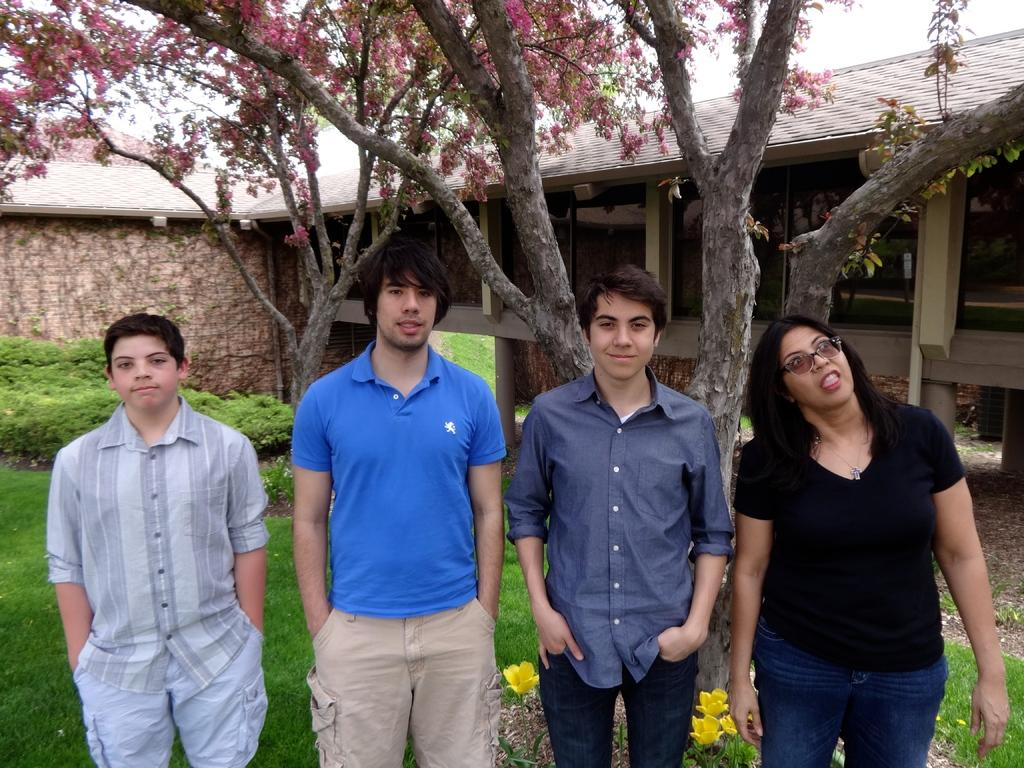What is the main focus of the image? There are people in the center of the image. What can be seen in the background of the image? In the background, there are flower trees, grassland, yellow color flowers, pillars, a pipe, a house, and the sky. Can you describe the vegetation in the background? The background features flower trees and yellow color flowers. What type of structure is visible in the background? There is a house in the background. Is there an airplane flying in the winter sky in the image? There is no airplane or winter sky present in the image. Can you see a pump in the background of the image? There is no pump visible in the background of the image. 